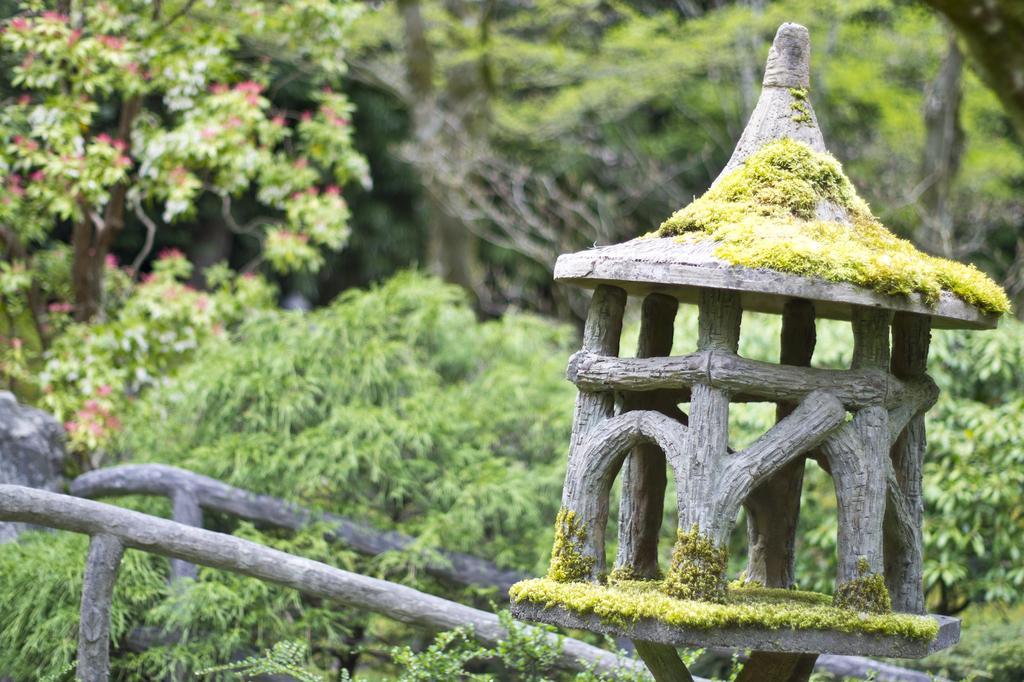Could you give a brief overview of what you see in this image? In the image we can see small house made with wooden blocks. Here we can see plants, trees and the background is slightly blurred. 